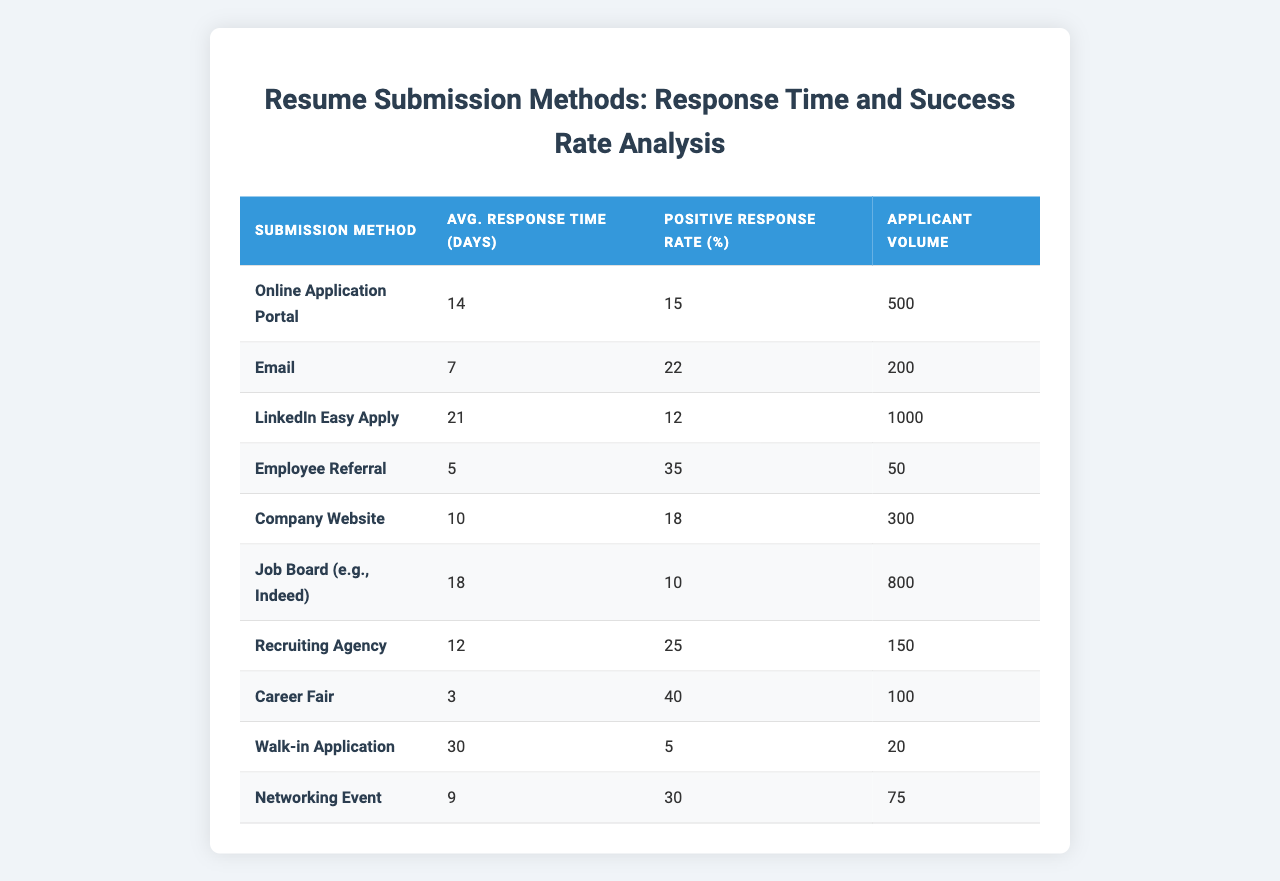What is the average response time for an Employee Referral? The average response time for an Employee Referral is 5 days, as indicated in the corresponding row of the table.
Answer: 5 days Which submission method has the longest average response time? The submission method with the longest average response time is Walk-in Application, which takes 30 days to respond.
Answer: Walk-in Application What is the positive response rate for LinkedIn Easy Apply? The positive response rate for LinkedIn Easy Apply is 12%, as shown in the table.
Answer: 12% What is the sum of the applicant volume for Job Board (e.g., Indeed) and Email? The applicant volume for Job Board is 800 and for Email is 200. Adding these gives 800 + 200 = 1000.
Answer: 1000 Is the positive response rate for Email higher than that for Company Website? The positive response rate for Email is 22% while for Company Website it is 18%. Since 22% is greater than 18%, the statement is true.
Answer: Yes Which submission methods have a positive response rate greater than 20%? The submission methods with a positive response rate greater than 20% are Email (22%), Employee Referral (35%), and Networking Event (30%). This is determined by comparing each method's positive response rate to 20%.
Answer: Email, Employee Referral, Networking Event What is the median average response time for the submission methods? To find the median, we first list the average response times: [14, 7, 21, 5, 10, 18, 12, 3, 30, 9]. Arranging them in ascending order gives us [3, 5, 7, 9, 10, 12, 14, 18, 21, 30]. The median is the average of the 5th and 6th values, (10 + 12) / 2 = 11.
Answer: 11 How many submission methods have an average response time of less than or equal to 10 days? The submission methods with an average response time less than or equal to 10 days are Employee Referral (5), Walk-in Application (30), and Company Website (10). Counting these gives 4 methods: [5, 9, 7, 10].
Answer: 4 What is the average positive response rate across all submission methods? To calculate the average positive response rate, sum all response rates: (15 + 22 + 12 + 35 + 18 + 10 + 25 + 40 + 5 + 30) = 207. Then divide by the number of methods (10), giving 207 / 10 = 20.7%.
Answer: 20.7% Which submission method has the highest applicant volume? The submission method with the highest applicant volume is LinkedIn Easy Apply, with a volume of 1000 applicants, as seen in the respective column of the table.
Answer: LinkedIn Easy Apply 